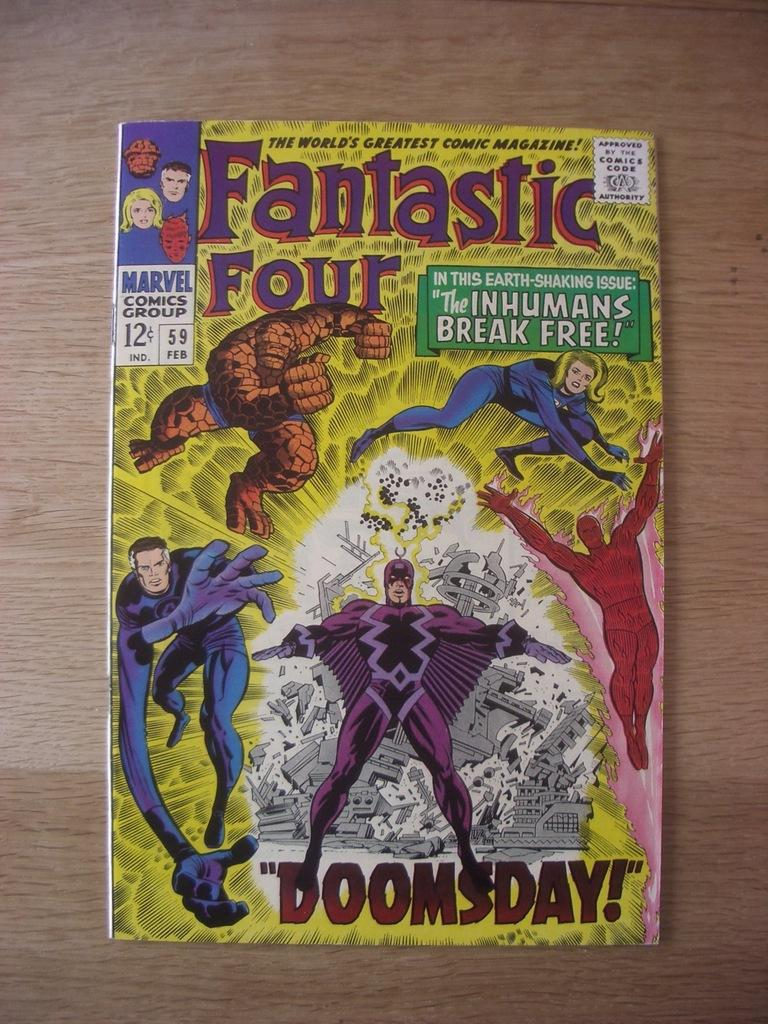<image>
Relay a brief, clear account of the picture shown. The Doomsday comic of Fantastic Four sits on a table in great condition. 